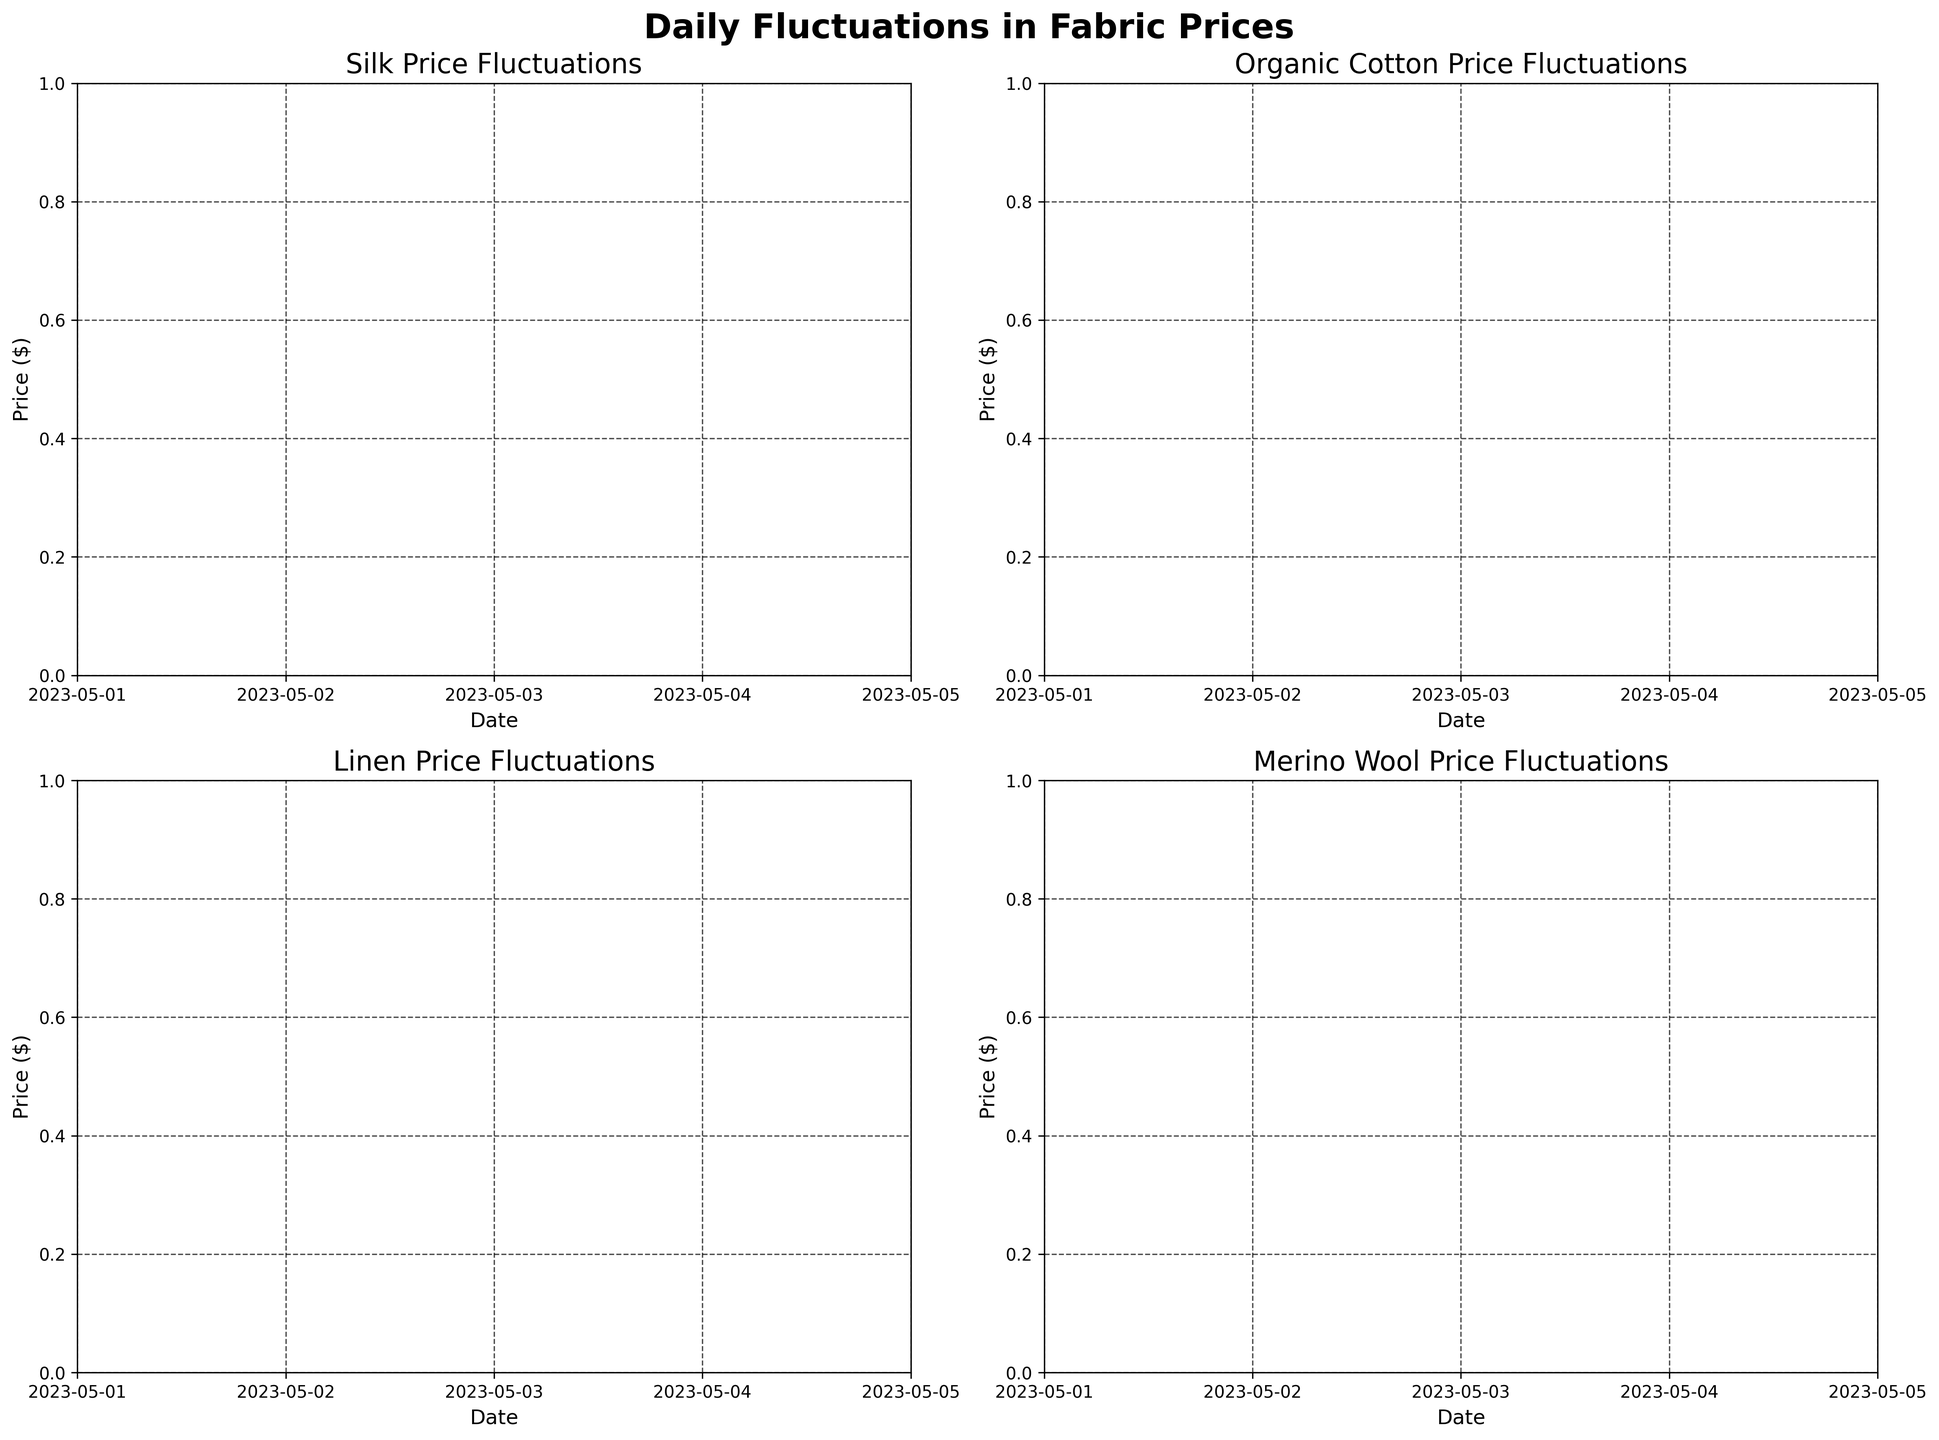What is the title of the figure? The title is usually at the top of the chart and typically summarizes the main information. Read the largest text at the top center of the figure.
Answer: Daily Fluctuations in Fabric Prices What is the price range for Silk on May 1st? To find the price range for Silk on May 1st, look for the minimum and maximum vertical lines corresponding to that date in the Silk subplot. The minimum is the bottom of the low line (22.15) and the maximum is the top of the high line (23.75).
Answer: 22.15 to 23.75 Which material had the highest closing price on May 5th? Look at the closing prices (ends of the horizontal close lines) for all materials on May 5th. Compare these values. Merino Wool's close price is the highest at 20.30.
Answer: Merino Wool By how much did the price of Linen increase from May 1st to May 3rd? Find the closing price of Linen on May 1st and May 3rd. Subtract the earlier close from the later close: 12.90 - 12.60 = 0.30.
Answer: 0.30 Which material had the smallest price fluctuation on May 2nd? For May 2nd, check the difference between the high and low for each material. Organic Cotton has the smallest difference: 6.20 - 5.85 = 0.35.
Answer: Organic Cotton What was the opening price for Merino Wool on May 4th? Check the opening horizontal line for Merino Wool on May 4th. Read the value at the left end of the line, which is typically marked at the start of the price range.
Answer: 19.90 Did the price of Silk ever close lower than it opened during the given dates? Look for instances where the close horizontal line is below the open horizontal line for Silk. This never occurs based on the given data.
Answer: No On which date did Organic Cotton have its highest closing price? Compare the closing prices for Organic Cotton across all dates. The highest closing price is 6.15, which occurred on May 2nd.
Answer: May 2nd By how much did the closing price of Merino Wool change from May 1st to May 5th? Subtract the closing price on May 1st from the closing price on May 5th: 20.30 - 19.30 = 1.00.
Answer: 1.00 